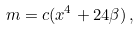Convert formula to latex. <formula><loc_0><loc_0><loc_500><loc_500>m = c ( x ^ { 4 } + 2 4 \beta ) \, ,</formula> 